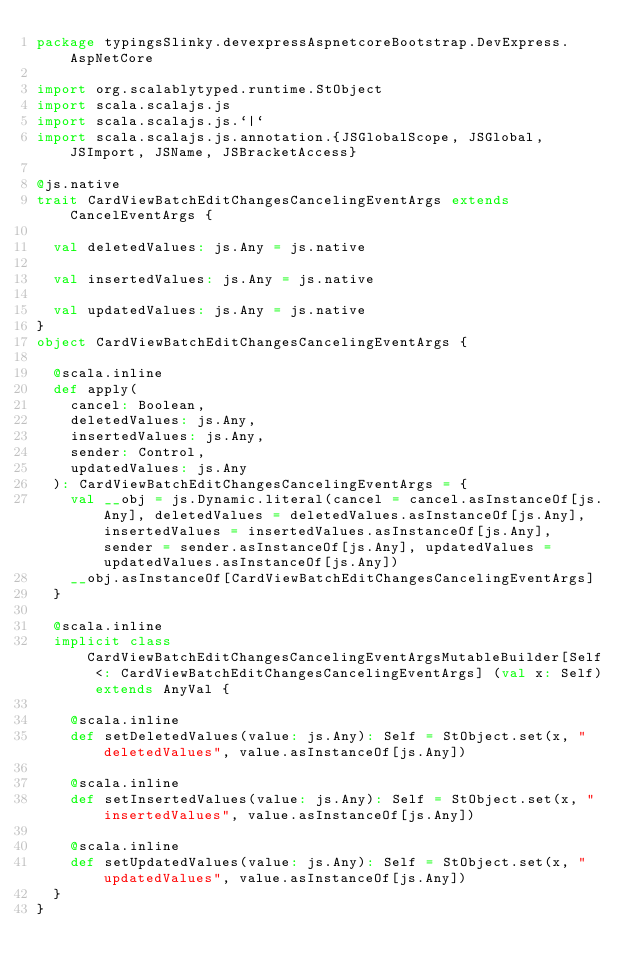<code> <loc_0><loc_0><loc_500><loc_500><_Scala_>package typingsSlinky.devexpressAspnetcoreBootstrap.DevExpress.AspNetCore

import org.scalablytyped.runtime.StObject
import scala.scalajs.js
import scala.scalajs.js.`|`
import scala.scalajs.js.annotation.{JSGlobalScope, JSGlobal, JSImport, JSName, JSBracketAccess}

@js.native
trait CardViewBatchEditChangesCancelingEventArgs extends CancelEventArgs {
  
  val deletedValues: js.Any = js.native
  
  val insertedValues: js.Any = js.native
  
  val updatedValues: js.Any = js.native
}
object CardViewBatchEditChangesCancelingEventArgs {
  
  @scala.inline
  def apply(
    cancel: Boolean,
    deletedValues: js.Any,
    insertedValues: js.Any,
    sender: Control,
    updatedValues: js.Any
  ): CardViewBatchEditChangesCancelingEventArgs = {
    val __obj = js.Dynamic.literal(cancel = cancel.asInstanceOf[js.Any], deletedValues = deletedValues.asInstanceOf[js.Any], insertedValues = insertedValues.asInstanceOf[js.Any], sender = sender.asInstanceOf[js.Any], updatedValues = updatedValues.asInstanceOf[js.Any])
    __obj.asInstanceOf[CardViewBatchEditChangesCancelingEventArgs]
  }
  
  @scala.inline
  implicit class CardViewBatchEditChangesCancelingEventArgsMutableBuilder[Self <: CardViewBatchEditChangesCancelingEventArgs] (val x: Self) extends AnyVal {
    
    @scala.inline
    def setDeletedValues(value: js.Any): Self = StObject.set(x, "deletedValues", value.asInstanceOf[js.Any])
    
    @scala.inline
    def setInsertedValues(value: js.Any): Self = StObject.set(x, "insertedValues", value.asInstanceOf[js.Any])
    
    @scala.inline
    def setUpdatedValues(value: js.Any): Self = StObject.set(x, "updatedValues", value.asInstanceOf[js.Any])
  }
}
</code> 